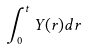Convert formula to latex. <formula><loc_0><loc_0><loc_500><loc_500>\int _ { 0 } ^ { t } Y ( r ) d r</formula> 